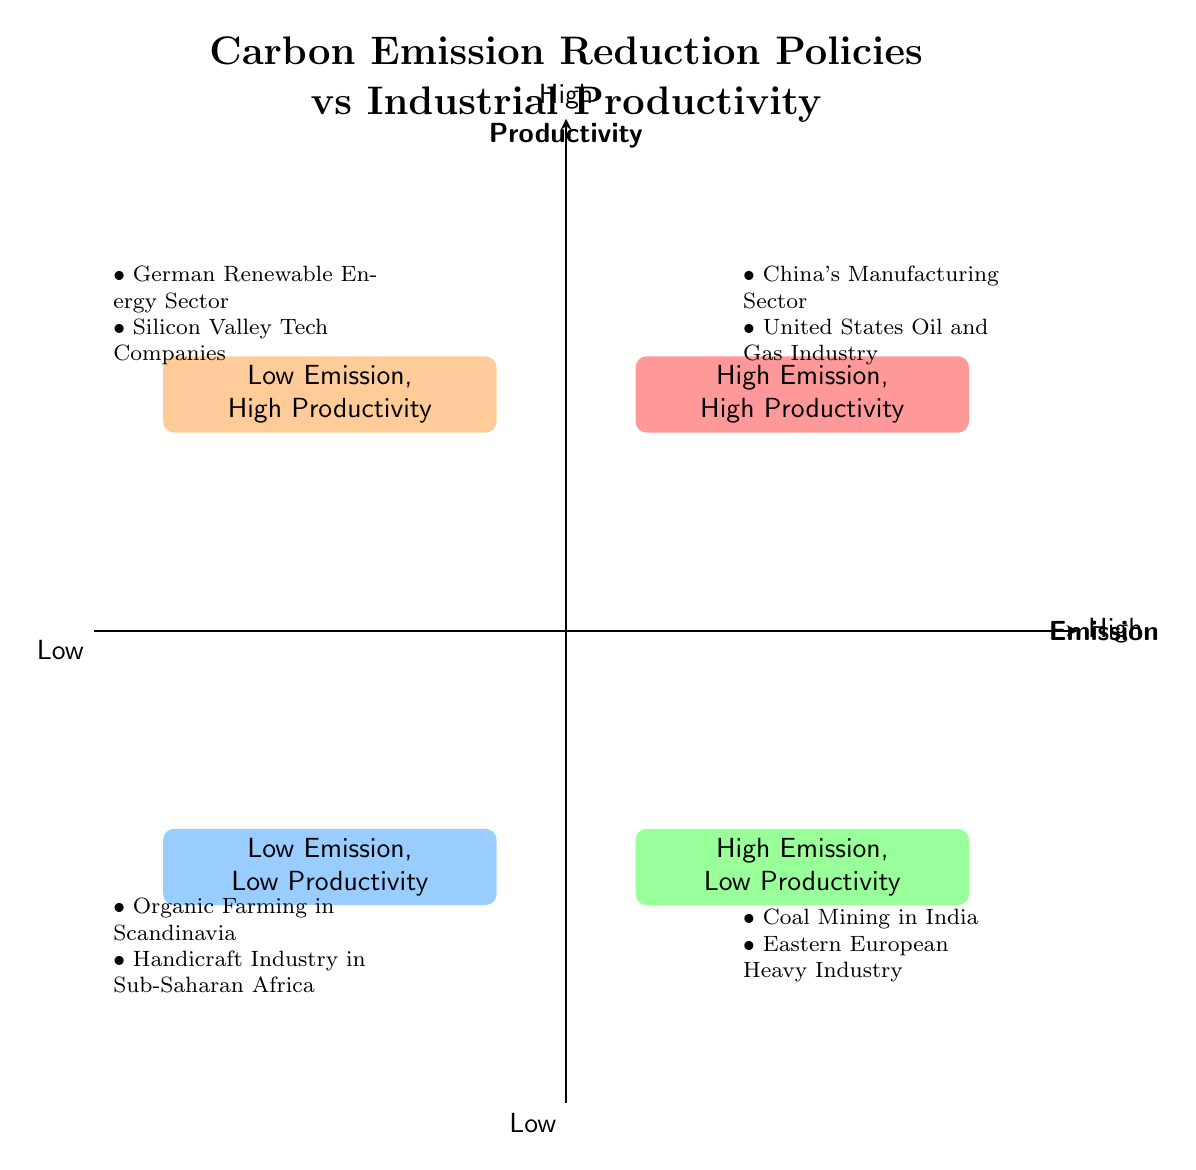What entities are in the "High Emission, High Productivity" quadrant? The "High Emission, High Productivity" quadrant includes "China's Manufacturing Sector" and the "United States Oil and Gas Industry." This is determined by examining the examples listed in that specific quadrant of the diagram.
Answer: China's Manufacturing Sector, United States Oil and Gas Industry Which quadrant has examples of "Low Emission, Low Productivity"? The "Low Emission, Low Productivity" quadrant lists examples such as "Organic Farming in Scandinavia" and "Handicraft Industry in Sub-Saharan Africa." This can be found by identifying the quadrant labeled with low emissions and productivity.
Answer: Low Emission, Low Productivity How many quadrants are shown in the diagram? The diagram illustrates four distinct quadrants: High Emission, High Productivity; Low Emission, High Productivity; High Emission, Low Productivity; and Low Emission, Low Productivity. Counting these labeled sections leads to the answer.
Answer: Four What is the relationship between emission levels and productivity in the "High Emission, Low Productivity" quadrant? In the "High Emission, Low Productivity" quadrant, there is a negative relationship indicated; despite high emissions from industries like "Coal Mining in India," their productivity levels are low. This is evident from the specific examples of both high emissions and low output listed in the quadrant.
Answer: Negative relationship Which sector is classified as having "Low Emission, High Productivity"? The "German Renewable Energy Sector" and "Silicon Valley Tech Companies" fall under the "Low Emission, High Productivity" category. This specific classification can be derived from the examples assigned to that quadrant in the diagram.
Answer: German Renewable Energy Sector, Silicon Valley Tech Companies 